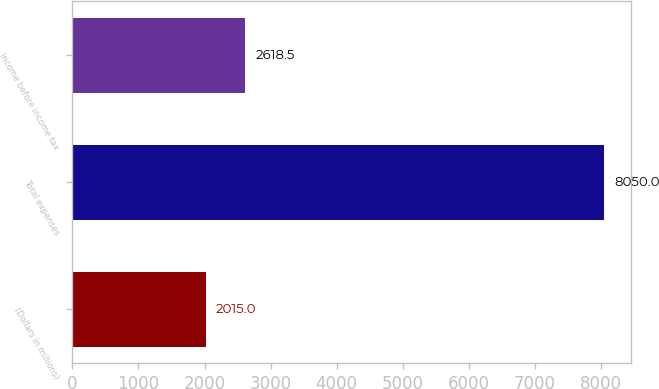Convert chart. <chart><loc_0><loc_0><loc_500><loc_500><bar_chart><fcel>(Dollars in millions)<fcel>Total expenses<fcel>Income before income tax<nl><fcel>2015<fcel>8050<fcel>2618.5<nl></chart> 